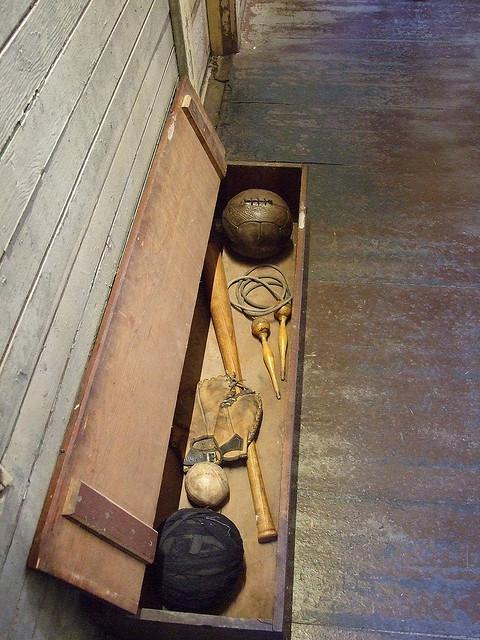Is this a tool box?
Concise answer only. No. How many balls are in the picture?
Be succinct. 3. What is in the box?
Write a very short answer. Sports equipment. 